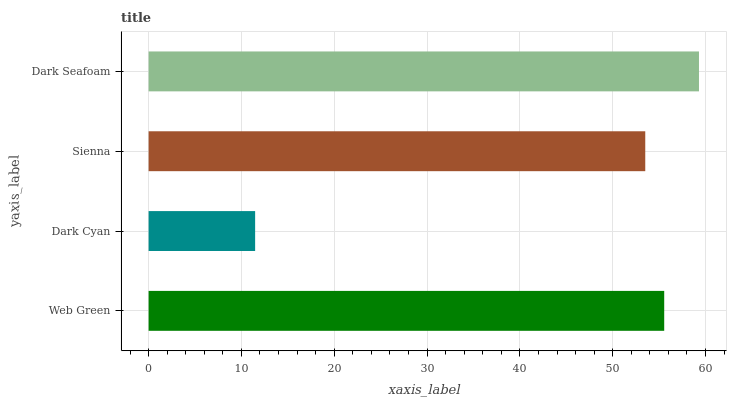Is Dark Cyan the minimum?
Answer yes or no. Yes. Is Dark Seafoam the maximum?
Answer yes or no. Yes. Is Sienna the minimum?
Answer yes or no. No. Is Sienna the maximum?
Answer yes or no. No. Is Sienna greater than Dark Cyan?
Answer yes or no. Yes. Is Dark Cyan less than Sienna?
Answer yes or no. Yes. Is Dark Cyan greater than Sienna?
Answer yes or no. No. Is Sienna less than Dark Cyan?
Answer yes or no. No. Is Web Green the high median?
Answer yes or no. Yes. Is Sienna the low median?
Answer yes or no. Yes. Is Sienna the high median?
Answer yes or no. No. Is Web Green the low median?
Answer yes or no. No. 